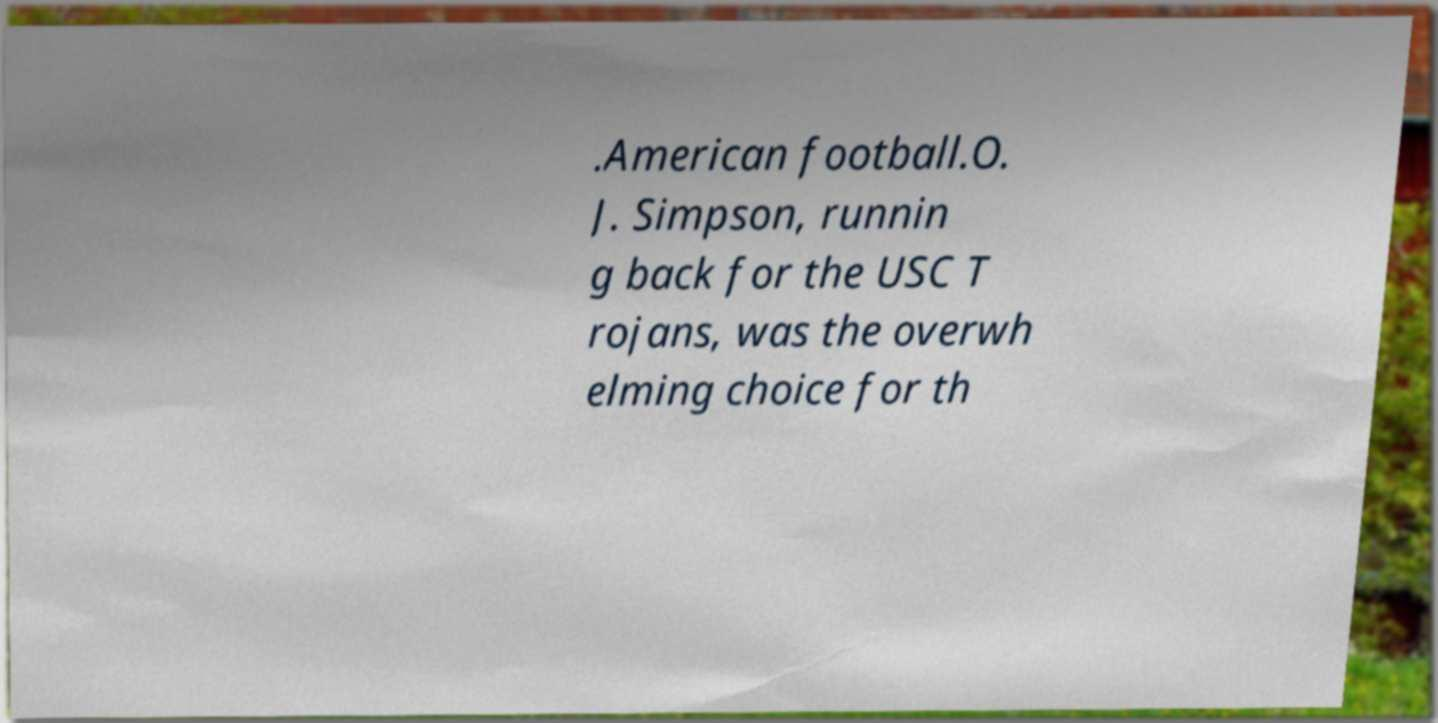Could you extract and type out the text from this image? .American football.O. J. Simpson, runnin g back for the USC T rojans, was the overwh elming choice for th 